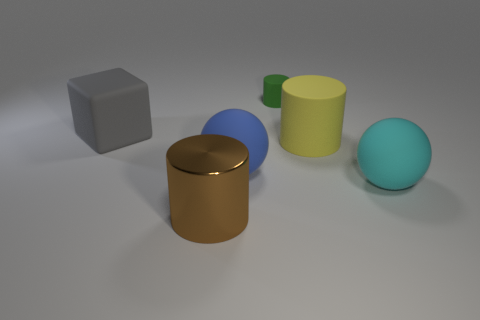Add 4 cyan rubber objects. How many objects exist? 10 Subtract all cubes. How many objects are left? 5 Subtract all blocks. Subtract all matte objects. How many objects are left? 0 Add 1 large brown objects. How many large brown objects are left? 2 Add 5 gray matte blocks. How many gray matte blocks exist? 6 Subtract 0 blue cylinders. How many objects are left? 6 